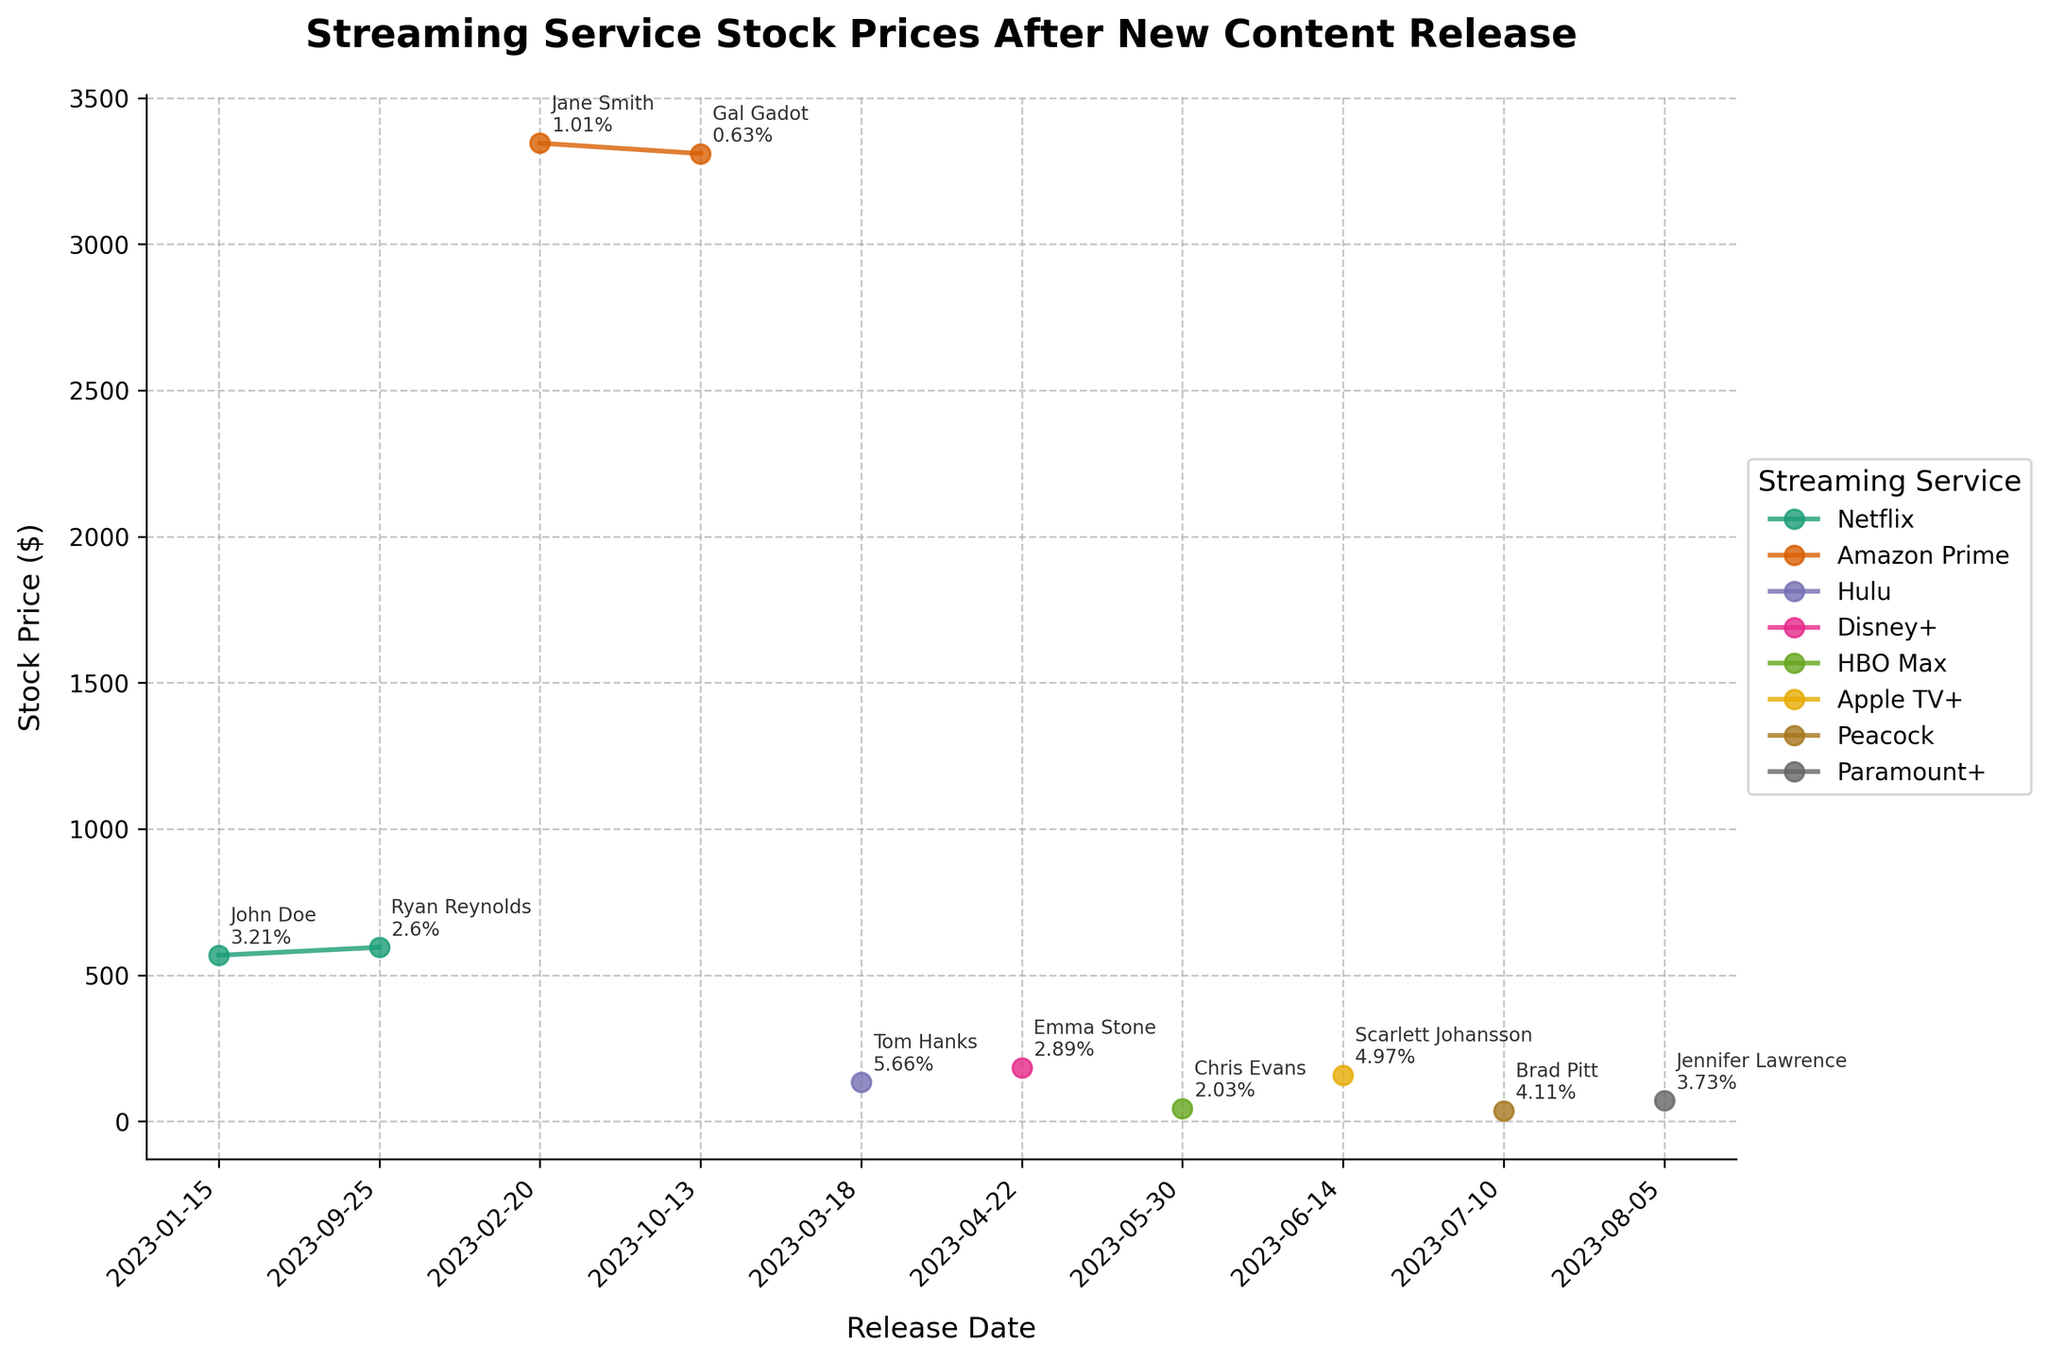How many streaming services are represented in the plot? Identify the number of unique streaming services by counting the distinct colors or labels in the legend. The data shows there are seven distinct services: Netflix, Amazon Prime, Hulu, Disney+, HBO Max, Apple TV+, and Peacock.
Answer: 7 Which streaming service had the highest stock price after the content release? Look at the y-axis values to identify the highest stock price after the release among the services. Amazon Prime shows the highest stock price after content release.
Answer: Amazon Prime What is the trend of Netflix's stock prices over the release dates? Observe the plot line for Netflix, represented in a specific color, and note the direction of the stock prices over time. Netflix's stock prices are increasing over the release dates.
Answer: Increasing Which star led to the highest percentage change in stock price for their respective streaming service? Look at the annotations next to the data points. Identify the highest percentage change and the associated star. Tom Hanks led to the highest percentage change for Hulu with 5.66%.
Answer: Tom Hanks Compare the stock price changes for Netflix when featuring John Doe and Ryan Reynolds. Note the stock prices before and after the release for both stars on Netflix and calculate or observe the percentage changes. John Doe led to a 3.21% increase and Ryan Reynolds led to a 2.6% increase.
Answer: John Doe had a higher percentage change What is the average stock price after the release for the two Amazon Prime releases? Identify the stock prices after the release for Amazon Prime (3345.90 for Jane Smith and 3310.22 for Gal Gadot). Calculate the average of these values: (3345.90 + 3310.22) / 2.
Answer: 3328.06 Which streaming service showed the least percentage change and what was the change? Scan the annotations to find the smallest percentage change and identify the corresponding streaming service. Amazon Prime with Gal Gadot had a 0.63% change.
Answer: Amazon Prime, 0.63% Order the stars by their impact on stock prices from lowest to highest percentage change. Observe the percentage changes annotated next to each data point and sort them. From lowest to highest: Gal Gadot (0.63%), Jane Smith (1.01%), Chris Evans (2.03%), Ryan Reynolds (2.6%), Emma Stone (2.89%), John Doe (3.21%), Jennifer Lawrence (3.73%), Brad Pitt (4.11%), Scarlett Johansson (4.97%), Tom Hanks (5.66%).
Answer: Gal Gadot, Jane Smith, Chris Evans, Ryan Reynolds, Emma Stone, John Doe, Jennifer Lawrence, Brad Pitt, Scarlett Johansson, Tom Hanks What was the percentage change in stock price for Apple TV+ when featuring Scarlett Johansson? Reference the annotation next to Scarlett Johansson's data point for Apple TV+. The annotation indicates a percentage change of 4.97%.
Answer: 4.97% Which streaming service had two releases, and who were the stars featured in those releases? Identify the service that appears twice in the legend or by the lines on the plot. Netflix had two releases featuring John Doe and Ryan Reynolds.
Answer: Netflix, John Doe and Ryan Reynolds 